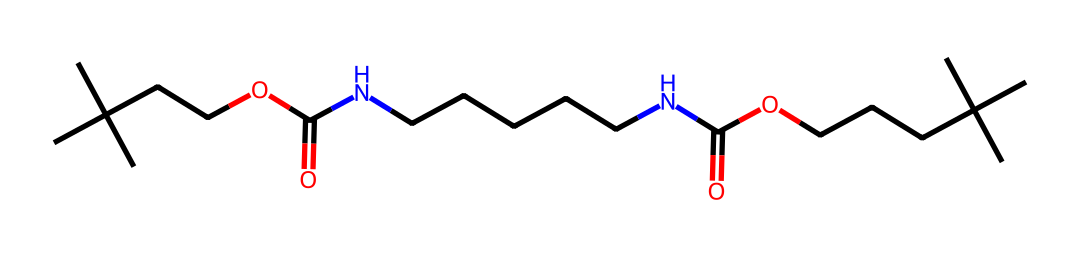What is the functional group present in this polyurethane? The structure contains multiple functional groups, but a prominent one is the amide functional group (-C(=O)N-), indicated by the presence of carbon double-bonded to oxygen and single-bonded to nitrogen.
Answer: amide How many carbon atoms are in this structure? By counting the 'C' characters in the SMILES representation and considering the branching, there are 24 carbon atoms present in the structure.
Answer: 24 What type of polymer does this chemical represent? The structure is representative of a type of polymer known as polyurethane, characterized by the repeating units containing isocyanate and alcohol groups forming urethane linkages.
Answer: polyurethane Is this chemical saturated or unsaturated? The presence of only single bonds between carbon atoms and the lack of carbon-carbon double bonds indicates that this chemical is saturated.
Answer: saturated What is the primary purpose of this polyurethane in basketball shoes? The structural characteristics like flexibility and cushioning found in polyurethane make it beneficial in basketball shoes for performance and comfort.
Answer: cushioning What type of bonding primarily occurs in this polyurethane structure? The main type of bonding in this polyurethane structure is covalent bonding, where atoms share electrons to form the polymer network.
Answer: covalent 